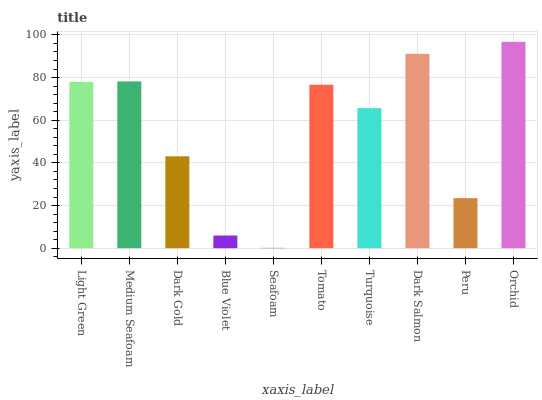Is Seafoam the minimum?
Answer yes or no. Yes. Is Orchid the maximum?
Answer yes or no. Yes. Is Medium Seafoam the minimum?
Answer yes or no. No. Is Medium Seafoam the maximum?
Answer yes or no. No. Is Medium Seafoam greater than Light Green?
Answer yes or no. Yes. Is Light Green less than Medium Seafoam?
Answer yes or no. Yes. Is Light Green greater than Medium Seafoam?
Answer yes or no. No. Is Medium Seafoam less than Light Green?
Answer yes or no. No. Is Tomato the high median?
Answer yes or no. Yes. Is Turquoise the low median?
Answer yes or no. Yes. Is Peru the high median?
Answer yes or no. No. Is Dark Gold the low median?
Answer yes or no. No. 